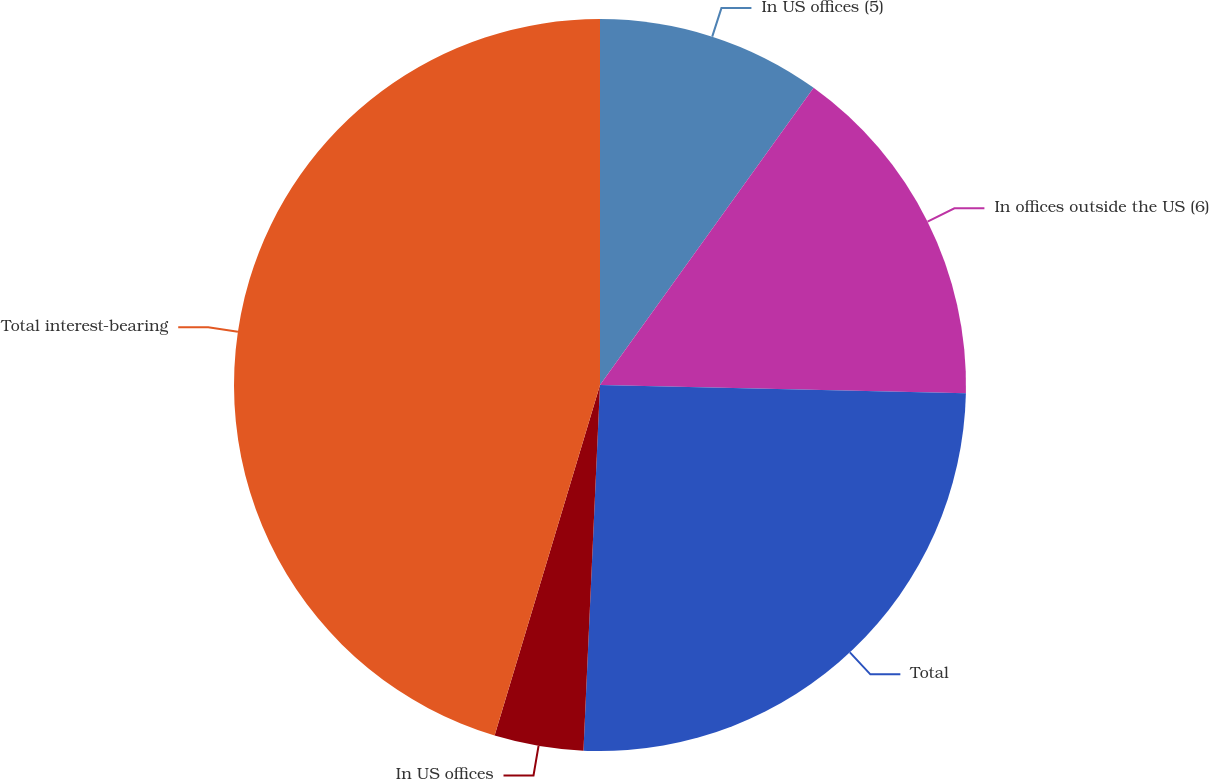Convert chart to OTSL. <chart><loc_0><loc_0><loc_500><loc_500><pie_chart><fcel>In US offices (5)<fcel>In offices outside the US (6)<fcel>Total<fcel>In US offices<fcel>Total interest-bearing<nl><fcel>9.92%<fcel>15.44%<fcel>25.36%<fcel>3.93%<fcel>45.35%<nl></chart> 